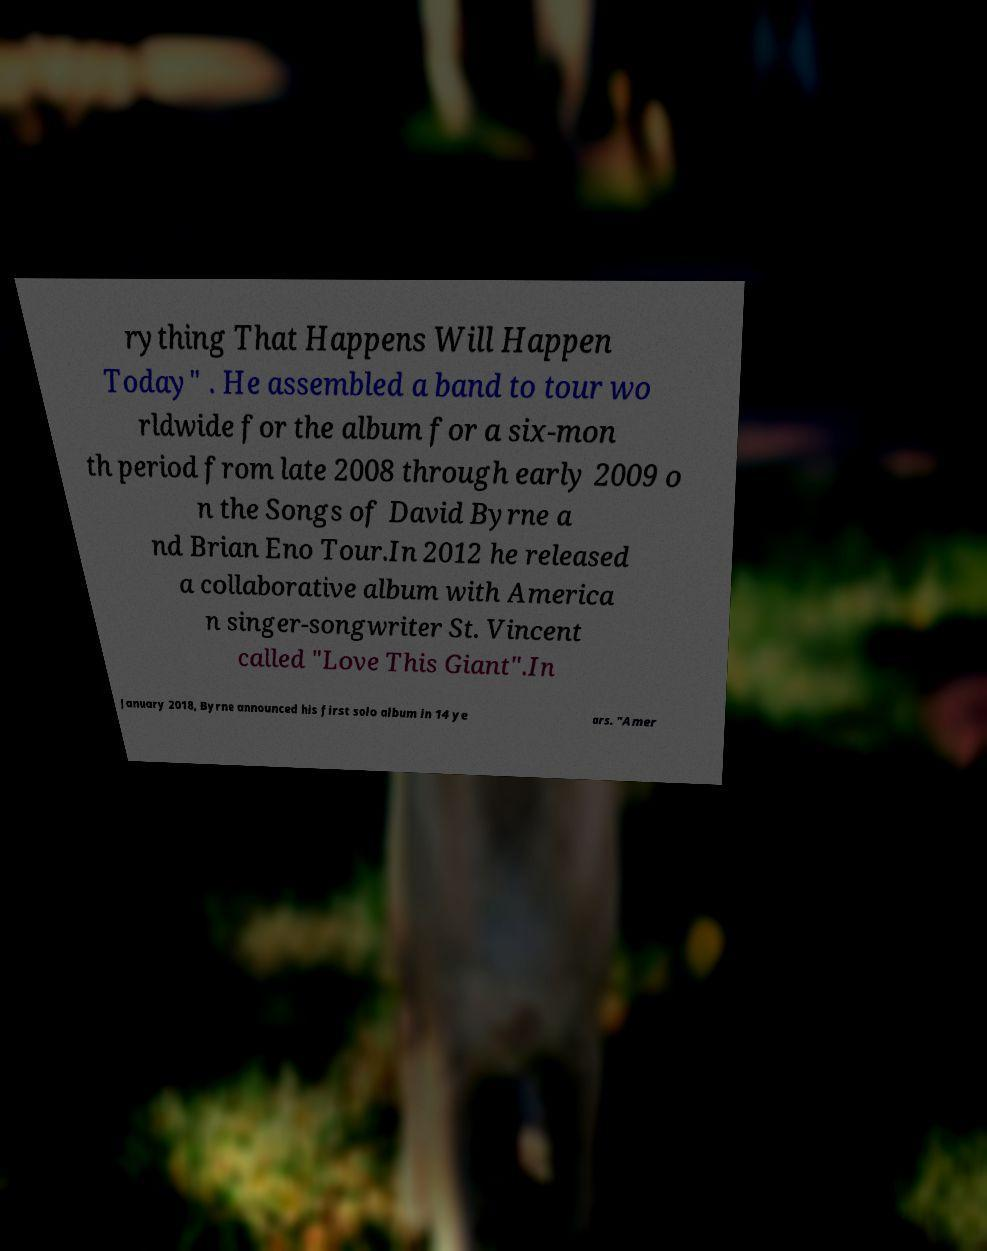Can you read and provide the text displayed in the image?This photo seems to have some interesting text. Can you extract and type it out for me? rything That Happens Will Happen Today" . He assembled a band to tour wo rldwide for the album for a six-mon th period from late 2008 through early 2009 o n the Songs of David Byrne a nd Brian Eno Tour.In 2012 he released a collaborative album with America n singer-songwriter St. Vincent called "Love This Giant".In January 2018, Byrne announced his first solo album in 14 ye ars. "Amer 